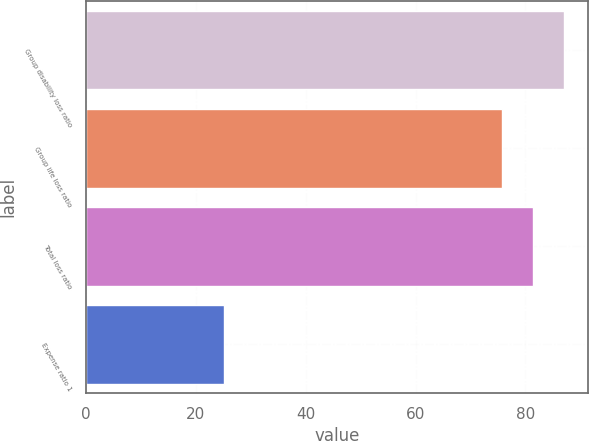Convert chart to OTSL. <chart><loc_0><loc_0><loc_500><loc_500><bar_chart><fcel>Group disability loss ratio<fcel>Group life loss ratio<fcel>Total loss ratio<fcel>Expense ratio 1<nl><fcel>86.96<fcel>75.7<fcel>81.33<fcel>25.1<nl></chart> 